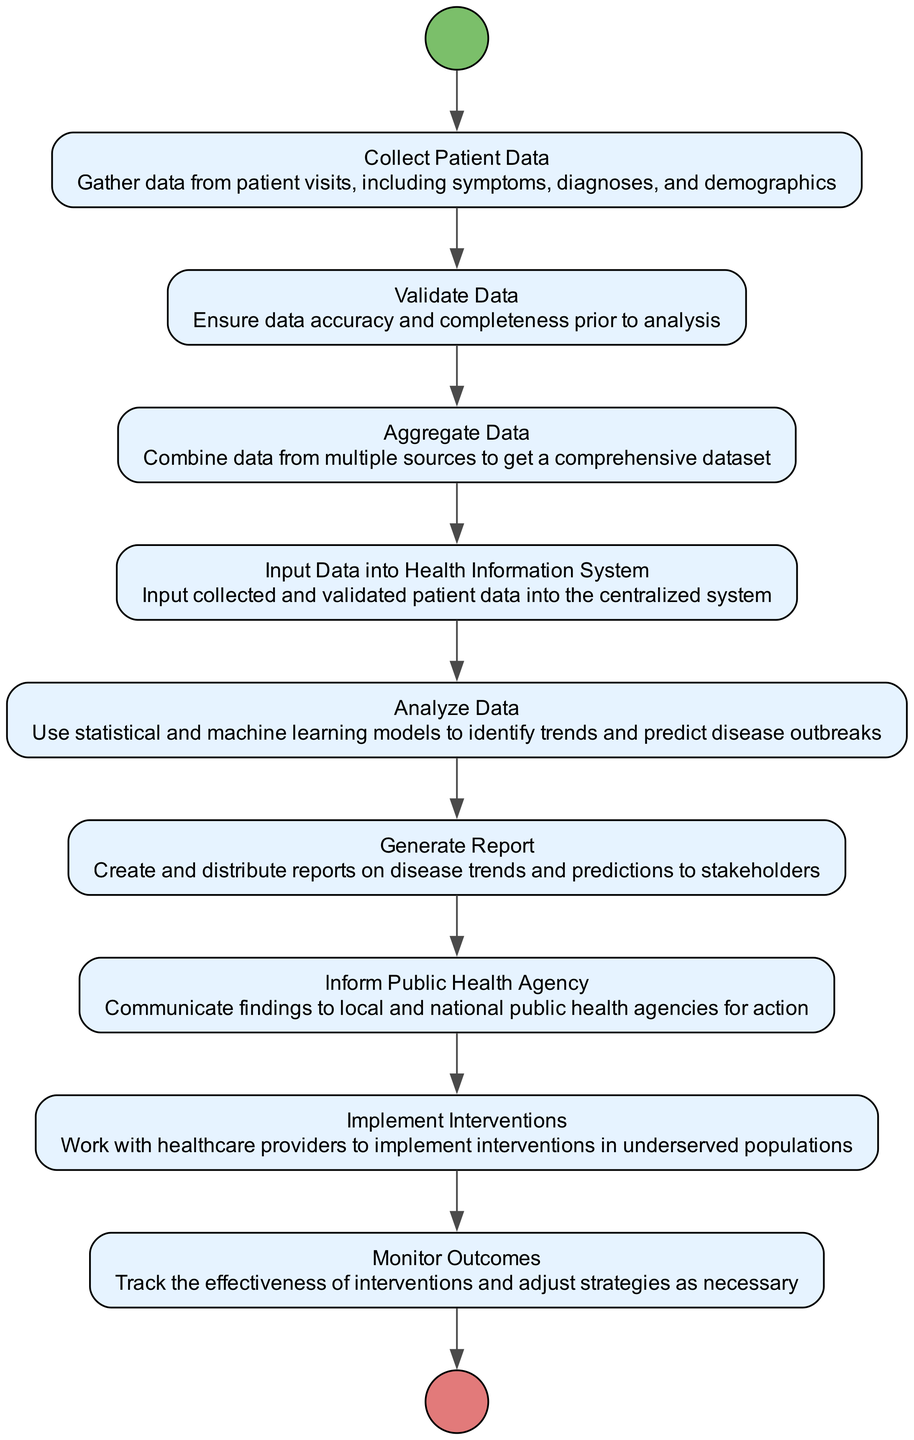What is the first activity in the diagram? The first activity is "Collect Patient Data", which is directly after the start event shown in the diagram.
Answer: Collect Patient Data How many activities are present in the diagram? By counting the activities represented in the nodes (excluding start and end events), there are a total of 8 activities.
Answer: 8 What does the "Validate Data" activity ensure? The "Validate Data" activity ensures data accuracy and completeness before further analysis, as described in its details.
Answer: Accuracy and completeness Which activity follows "Analyze Data"? The activity that follows "Analyze Data" is "Generate Report", which is the next step in the workflow of the diagram.
Answer: Generate Report What is the ultimate goal of informing the public health agency? The ultimate goal of informing the public health agency is to communicate findings for potential actions that may be needed to address public health concerns.
Answer: Communicate findings What is the last step in the process depicted in the diagram? The last step is the "End" event, which signifies the completion of the entire workflow after "Monitor Outcomes".
Answer: End How many transitions are there in total? There are 9 transitions that show the flow between nodes in the diagram, indicating the sequence of activities.
Answer: 9 What is done after the "Input Data into Health Information System"? After the "Input Data into Health Information System", the next step is "Analyze Data", which follows directly in the sequence.
Answer: Analyze Data What is the purpose of the "Implement Interventions" activity? The purpose of "Implement Interventions" is to collaborate with healthcare providers to address health issues in underserved populations based on findings from previous activities.
Answer: Address health issues 